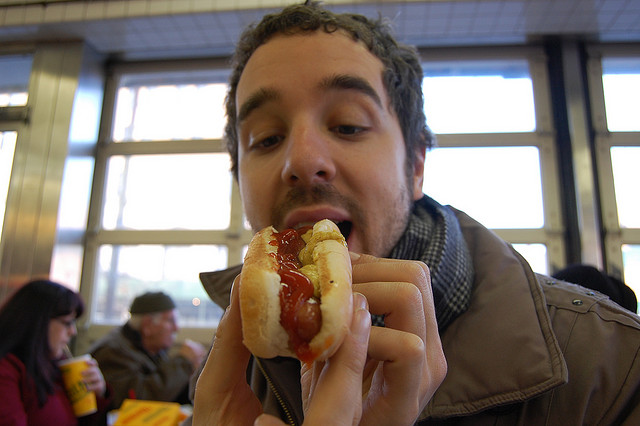What can you infer about the person's mood? The person seems to be in a good mood, as indicated by the slight smile on their face and the enjoyment apparent in the act of eating the hot dog. Such a casual moment often associates with contentment or a relaxed state of mind. 